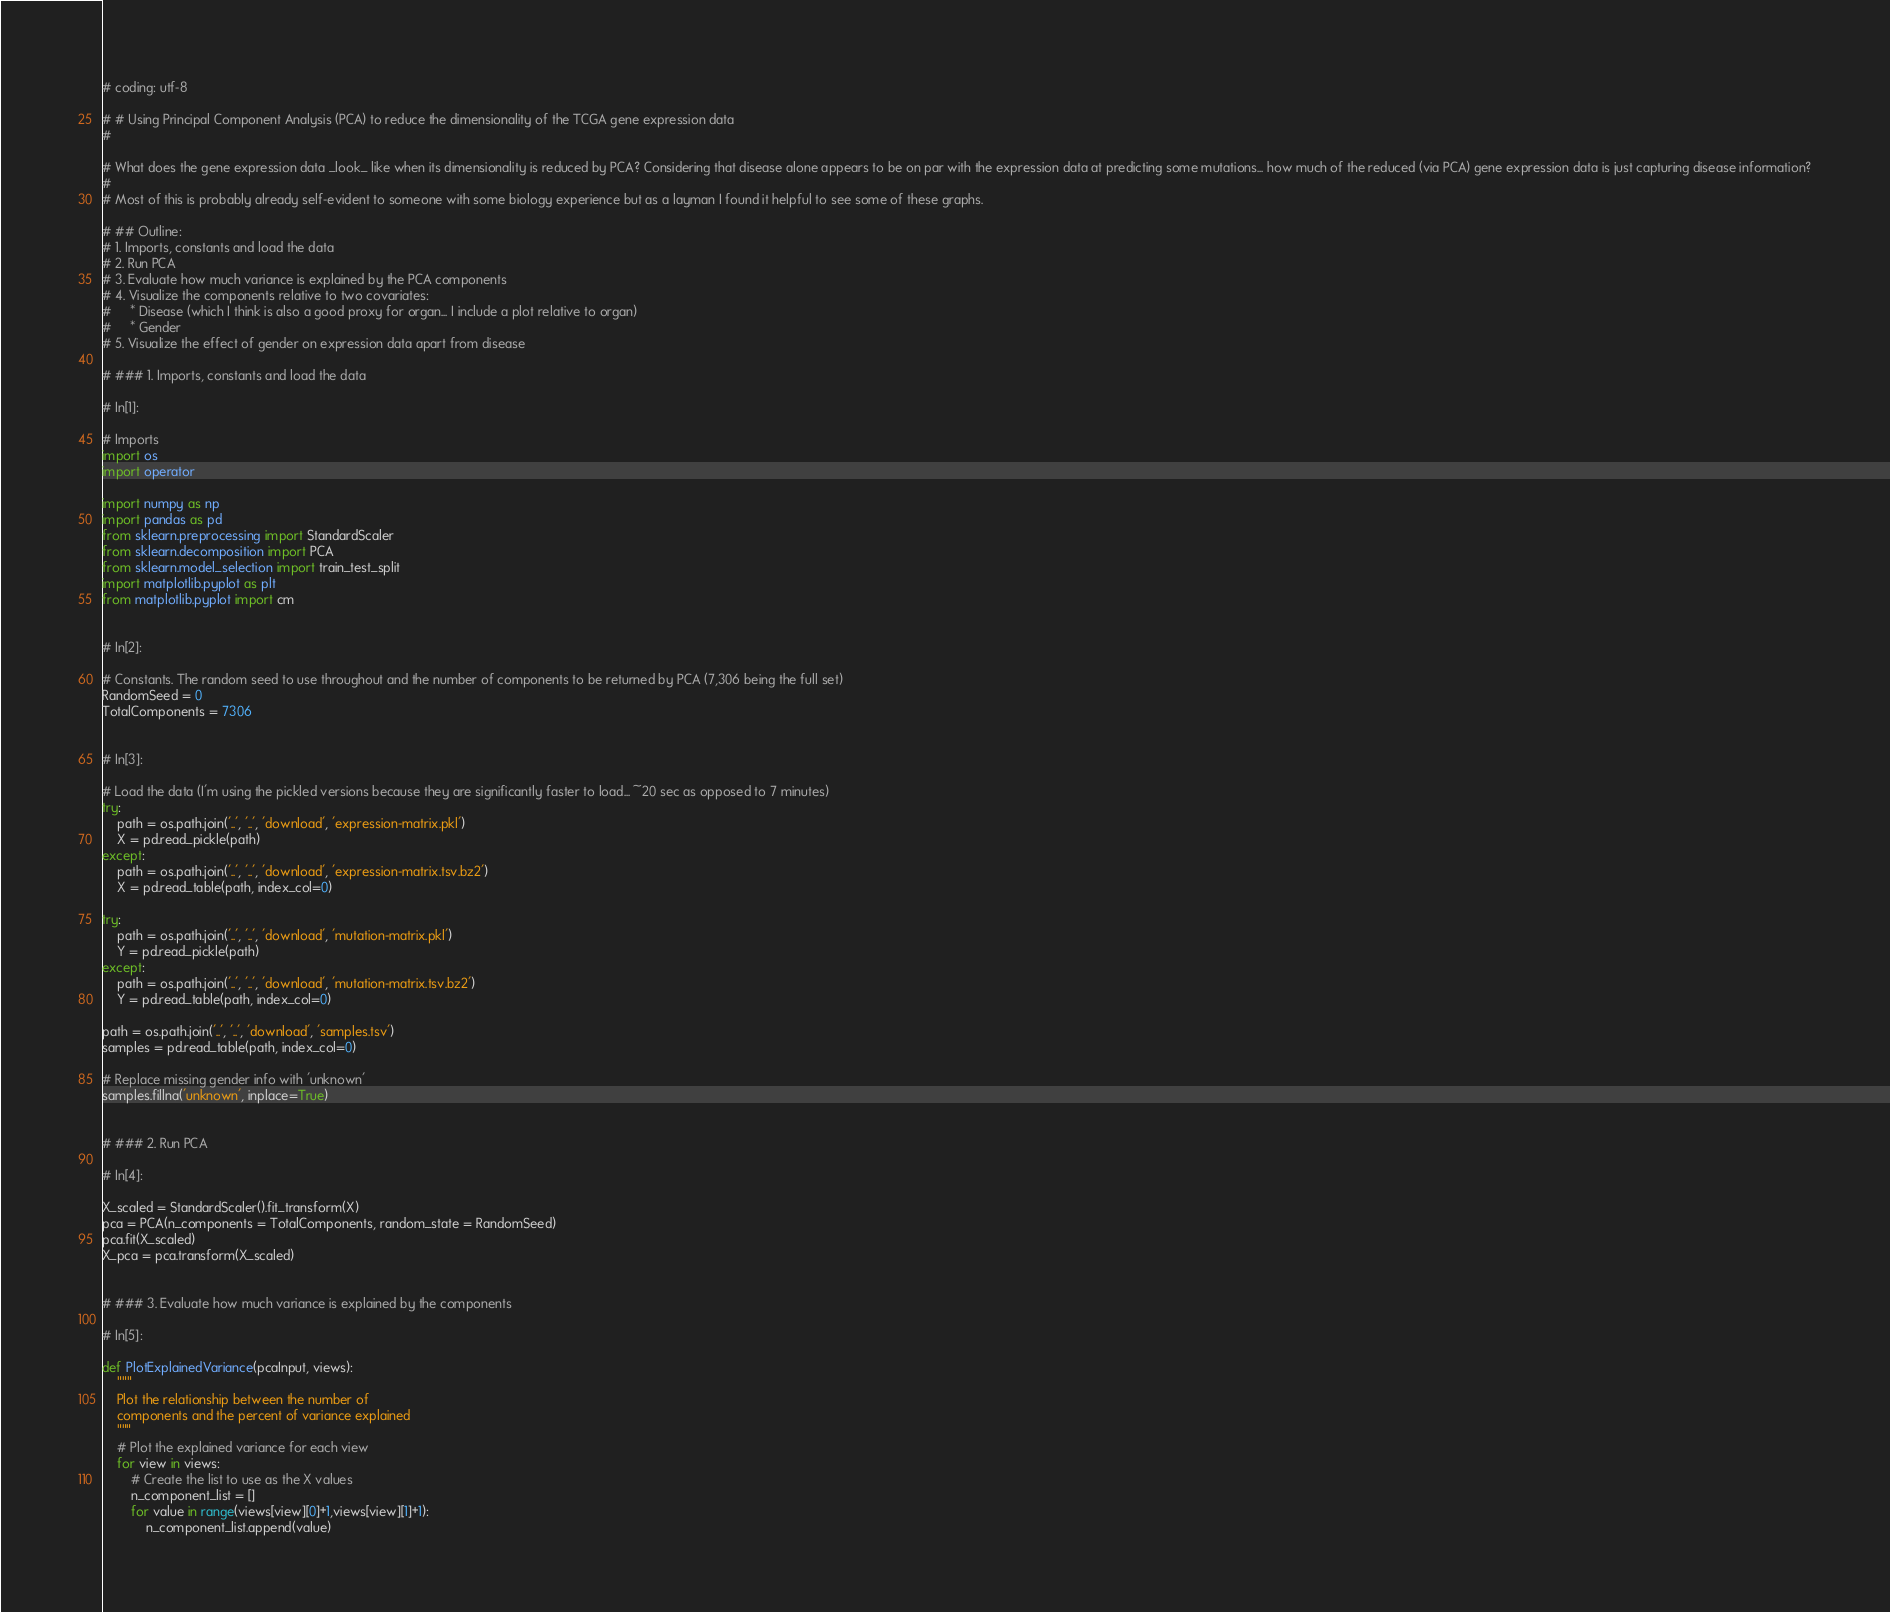<code> <loc_0><loc_0><loc_500><loc_500><_Python_>
# coding: utf-8

# # Using Principal Component Analysis (PCA) to reduce the dimensionality of the TCGA gene expression data
# 

# What does the gene expression data _look_ like when its dimensionality is reduced by PCA? Considering that disease alone appears to be on par with the expression data at predicting some mutations... how much of the reduced (via PCA) gene expression data is just capturing disease information?
# 
# Most of this is probably already self-evident to someone with some biology experience but as a layman I found it helpful to see some of these graphs.

# ## Outline:
# 1. Imports, constants and load the data
# 2. Run PCA
# 3. Evaluate how much variance is explained by the PCA components
# 4. Visualize the components relative to two covariates:
#     * Disease (which I think is also a good proxy for organ... I include a plot relative to organ)
#     * Gender
# 5. Visualize the effect of gender on expression data apart from disease

# ### 1. Imports, constants and load the data

# In[1]:

# Imports
import os
import operator

import numpy as np
import pandas as pd
from sklearn.preprocessing import StandardScaler
from sklearn.decomposition import PCA
from sklearn.model_selection import train_test_split
import matplotlib.pyplot as plt
from matplotlib.pyplot import cm


# In[2]:

# Constants. The random seed to use throughout and the number of components to be returned by PCA (7,306 being the full set)
RandomSeed = 0
TotalComponents = 7306


# In[3]:

# Load the data (I'm using the pickled versions because they are significantly faster to load... ~20 sec as opposed to 7 minutes)
try: 
    path = os.path.join('..', '..', 'download', 'expression-matrix.pkl')
    X = pd.read_pickle(path)
except:
    path = os.path.join('..', '..', 'download', 'expression-matrix.tsv.bz2')
    X = pd.read_table(path, index_col=0)

try:
    path = os.path.join('..', '..', 'download', 'mutation-matrix.pkl')
    Y = pd.read_pickle(path)
except:
    path = os.path.join('..', '..', 'download', 'mutation-matrix.tsv.bz2')
    Y = pd.read_table(path, index_col=0)
    
path = os.path.join('..', '..', 'download', 'samples.tsv')
samples = pd.read_table(path, index_col=0)

# Replace missing gender info with 'unknown'
samples.fillna('unknown', inplace=True)


# ### 2. Run PCA

# In[4]:

X_scaled = StandardScaler().fit_transform(X)
pca = PCA(n_components = TotalComponents, random_state = RandomSeed)
pca.fit(X_scaled)
X_pca = pca.transform(X_scaled)


# ### 3. Evaluate how much variance is explained by the components

# In[5]:

def PlotExplainedVariance(pcaInput, views):
    """ 
    Plot the relationship between the number of 
    components and the percent of variance explained
    """
    # Plot the explained variance for each view
    for view in views:
        # Create the list to use as the X values
        n_component_list = []
        for value in range(views[view][0]+1,views[view][1]+1):
            n_component_list.append(value)</code> 